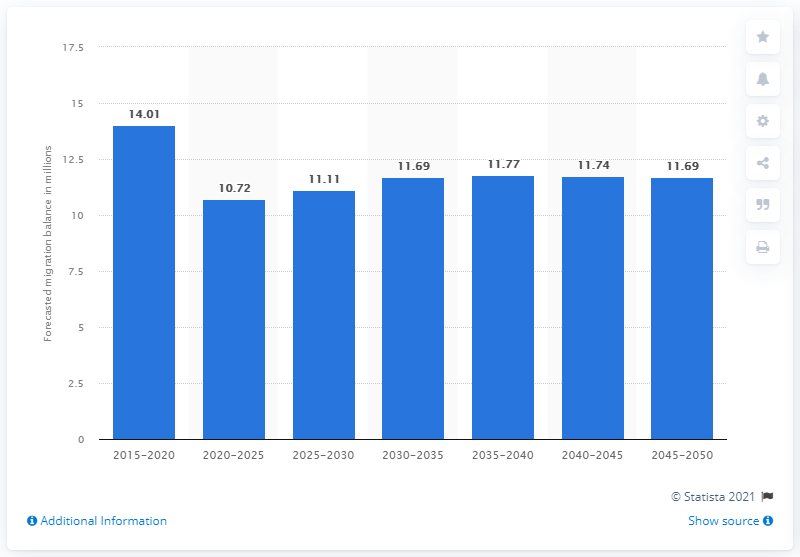Give some essential details in this illustration. Approximately 11.69 people are projected to migrate between the years 2045 and 2050. The net migration balance of developed regions from 2015 to 2020 was 14.01. 